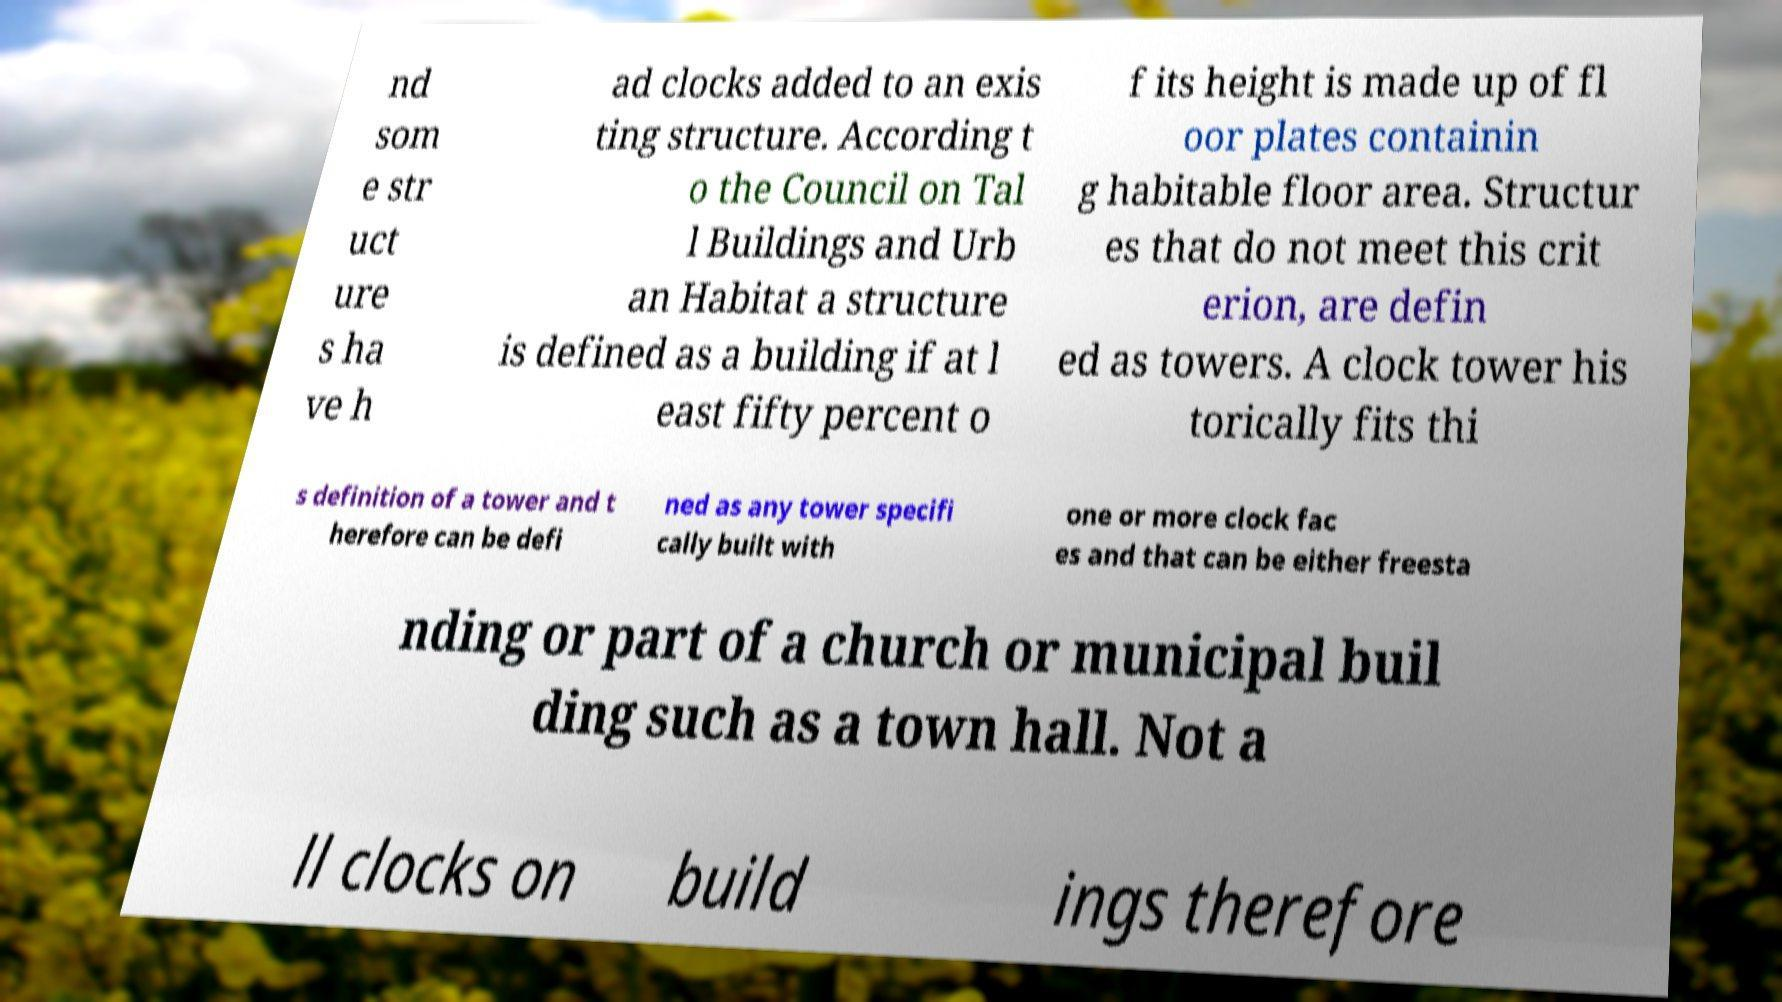Please identify and transcribe the text found in this image. nd som e str uct ure s ha ve h ad clocks added to an exis ting structure. According t o the Council on Tal l Buildings and Urb an Habitat a structure is defined as a building if at l east fifty percent o f its height is made up of fl oor plates containin g habitable floor area. Structur es that do not meet this crit erion, are defin ed as towers. A clock tower his torically fits thi s definition of a tower and t herefore can be defi ned as any tower specifi cally built with one or more clock fac es and that can be either freesta nding or part of a church or municipal buil ding such as a town hall. Not a ll clocks on build ings therefore 